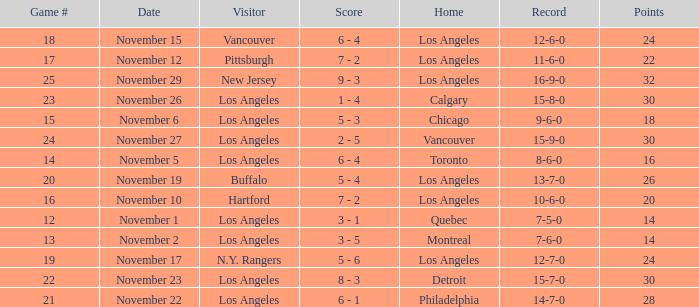What is the number of points of the game less than number 17 with an 11-6-0 record? None. 